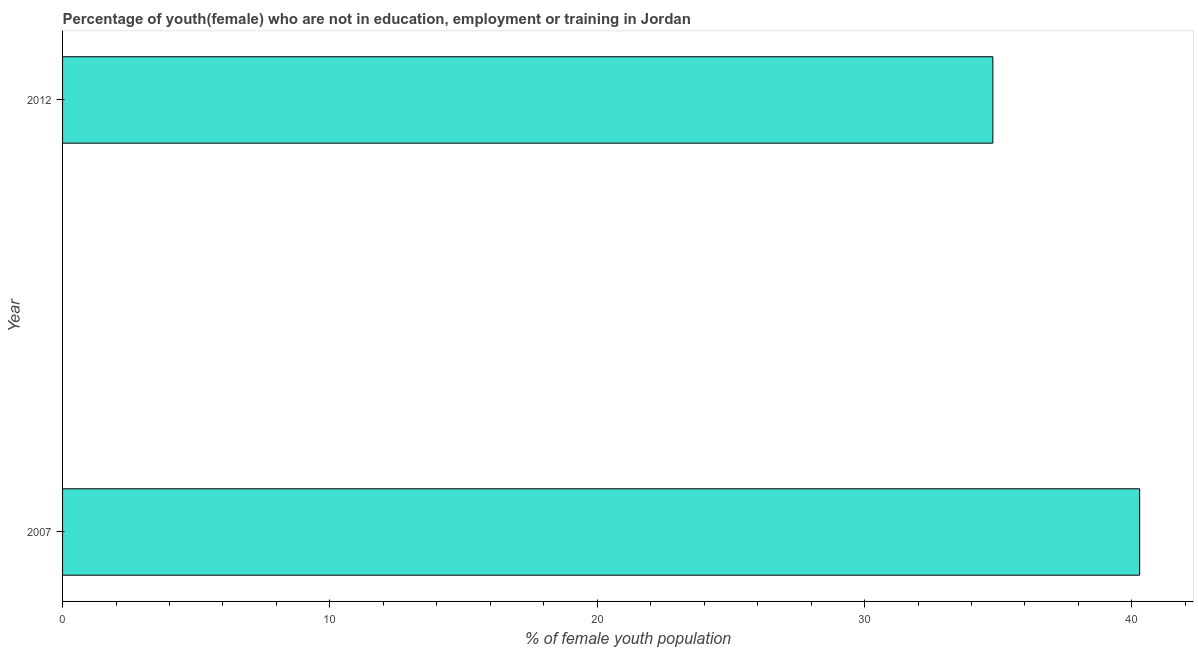Does the graph contain grids?
Your answer should be very brief. No. What is the title of the graph?
Offer a very short reply. Percentage of youth(female) who are not in education, employment or training in Jordan. What is the label or title of the X-axis?
Give a very brief answer. % of female youth population. What is the unemployed female youth population in 2007?
Your response must be concise. 40.29. Across all years, what is the maximum unemployed female youth population?
Ensure brevity in your answer.  40.29. Across all years, what is the minimum unemployed female youth population?
Give a very brief answer. 34.8. In which year was the unemployed female youth population maximum?
Keep it short and to the point. 2007. What is the sum of the unemployed female youth population?
Keep it short and to the point. 75.09. What is the difference between the unemployed female youth population in 2007 and 2012?
Make the answer very short. 5.49. What is the average unemployed female youth population per year?
Your response must be concise. 37.55. What is the median unemployed female youth population?
Your answer should be compact. 37.55. In how many years, is the unemployed female youth population greater than 4 %?
Your answer should be compact. 2. Do a majority of the years between 2007 and 2012 (inclusive) have unemployed female youth population greater than 40 %?
Ensure brevity in your answer.  No. What is the ratio of the unemployed female youth population in 2007 to that in 2012?
Provide a succinct answer. 1.16. Is the unemployed female youth population in 2007 less than that in 2012?
Keep it short and to the point. No. Are all the bars in the graph horizontal?
Provide a succinct answer. Yes. How many years are there in the graph?
Provide a short and direct response. 2. What is the % of female youth population in 2007?
Provide a succinct answer. 40.29. What is the % of female youth population in 2012?
Ensure brevity in your answer.  34.8. What is the difference between the % of female youth population in 2007 and 2012?
Make the answer very short. 5.49. What is the ratio of the % of female youth population in 2007 to that in 2012?
Offer a very short reply. 1.16. 